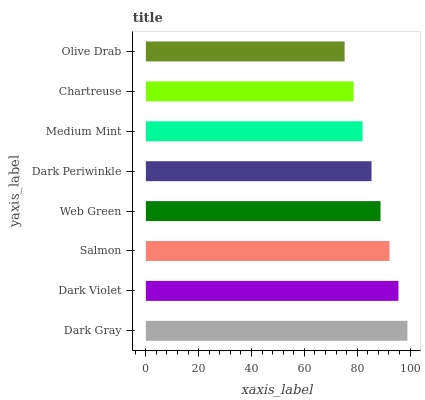Is Olive Drab the minimum?
Answer yes or no. Yes. Is Dark Gray the maximum?
Answer yes or no. Yes. Is Dark Violet the minimum?
Answer yes or no. No. Is Dark Violet the maximum?
Answer yes or no. No. Is Dark Gray greater than Dark Violet?
Answer yes or no. Yes. Is Dark Violet less than Dark Gray?
Answer yes or no. Yes. Is Dark Violet greater than Dark Gray?
Answer yes or no. No. Is Dark Gray less than Dark Violet?
Answer yes or no. No. Is Web Green the high median?
Answer yes or no. Yes. Is Dark Periwinkle the low median?
Answer yes or no. Yes. Is Salmon the high median?
Answer yes or no. No. Is Salmon the low median?
Answer yes or no. No. 